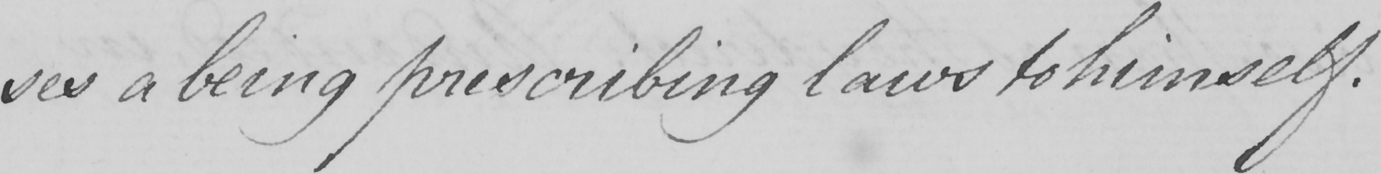Can you read and transcribe this handwriting? -ses a being prescribing laws to himself . 